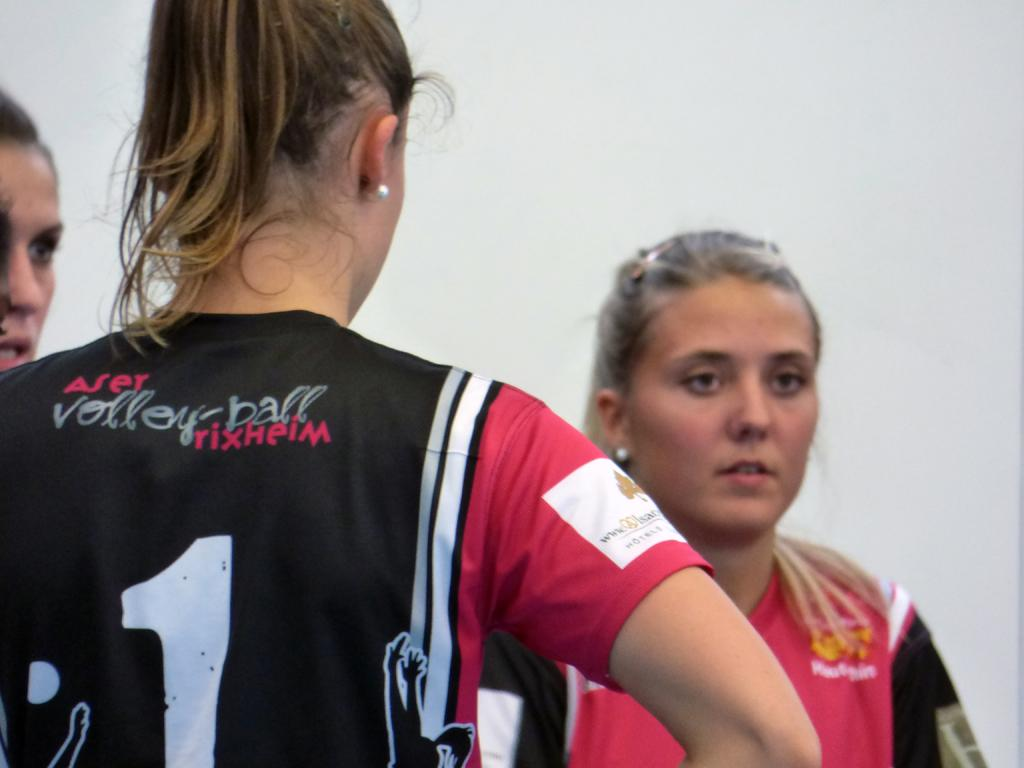<image>
Give a short and clear explanation of the subsequent image. Three volleyball players are discussing their current strategy. 